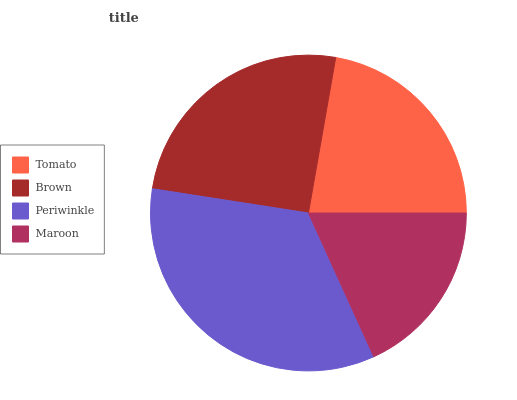Is Maroon the minimum?
Answer yes or no. Yes. Is Periwinkle the maximum?
Answer yes or no. Yes. Is Brown the minimum?
Answer yes or no. No. Is Brown the maximum?
Answer yes or no. No. Is Brown greater than Tomato?
Answer yes or no. Yes. Is Tomato less than Brown?
Answer yes or no. Yes. Is Tomato greater than Brown?
Answer yes or no. No. Is Brown less than Tomato?
Answer yes or no. No. Is Brown the high median?
Answer yes or no. Yes. Is Tomato the low median?
Answer yes or no. Yes. Is Periwinkle the high median?
Answer yes or no. No. Is Periwinkle the low median?
Answer yes or no. No. 